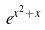Convert formula to latex. <formula><loc_0><loc_0><loc_500><loc_500>e ^ { x ^ { 2 } + x }</formula> 